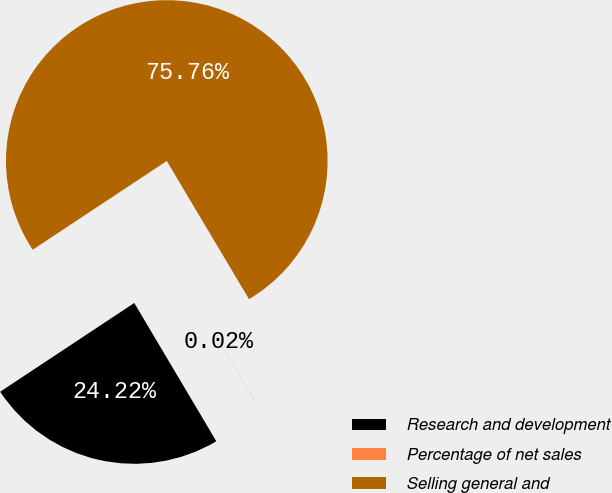<chart> <loc_0><loc_0><loc_500><loc_500><pie_chart><fcel>Research and development<fcel>Percentage of net sales<fcel>Selling general and<nl><fcel>24.22%<fcel>0.02%<fcel>75.76%<nl></chart> 